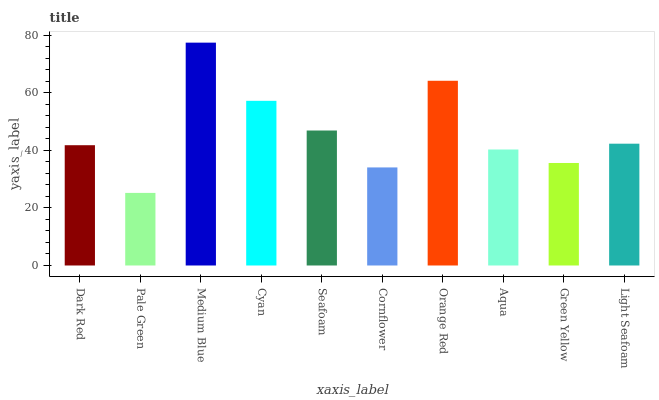Is Pale Green the minimum?
Answer yes or no. Yes. Is Medium Blue the maximum?
Answer yes or no. Yes. Is Medium Blue the minimum?
Answer yes or no. No. Is Pale Green the maximum?
Answer yes or no. No. Is Medium Blue greater than Pale Green?
Answer yes or no. Yes. Is Pale Green less than Medium Blue?
Answer yes or no. Yes. Is Pale Green greater than Medium Blue?
Answer yes or no. No. Is Medium Blue less than Pale Green?
Answer yes or no. No. Is Light Seafoam the high median?
Answer yes or no. Yes. Is Dark Red the low median?
Answer yes or no. Yes. Is Green Yellow the high median?
Answer yes or no. No. Is Green Yellow the low median?
Answer yes or no. No. 